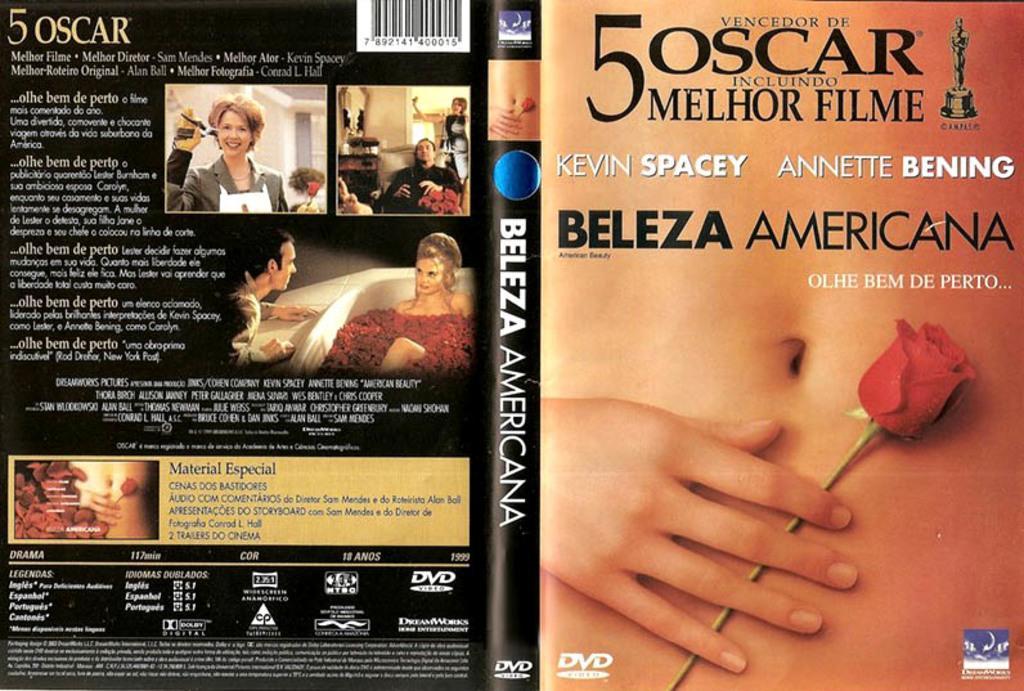Please provide a concise description of this image. This is an edited image. On the right we can see the hand and the stomach of a person and we can see a red rose and we can see the pictures of group of persons and pictures of many other objects and we can see the text, numbers, bar code and some pictures on the image. 